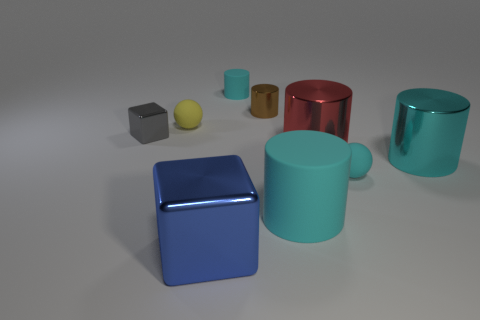Subtract all cyan cylinders. How many were subtracted if there are1cyan cylinders left? 2 Subtract all purple balls. How many cyan cylinders are left? 3 Subtract all brown cylinders. How many cylinders are left? 4 Subtract all red cylinders. How many cylinders are left? 4 Subtract all yellow cylinders. Subtract all gray balls. How many cylinders are left? 5 Add 1 tiny rubber objects. How many objects exist? 10 Subtract all cylinders. How many objects are left? 4 Subtract 0 blue cylinders. How many objects are left? 9 Subtract all tiny yellow objects. Subtract all red cylinders. How many objects are left? 7 Add 5 blue blocks. How many blue blocks are left? 6 